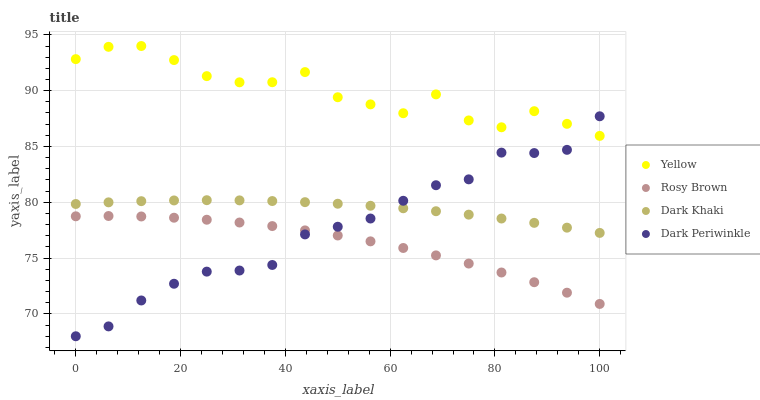Does Rosy Brown have the minimum area under the curve?
Answer yes or no. Yes. Does Yellow have the maximum area under the curve?
Answer yes or no. Yes. Does Dark Periwinkle have the minimum area under the curve?
Answer yes or no. No. Does Dark Periwinkle have the maximum area under the curve?
Answer yes or no. No. Is Dark Khaki the smoothest?
Answer yes or no. Yes. Is Yellow the roughest?
Answer yes or no. Yes. Is Rosy Brown the smoothest?
Answer yes or no. No. Is Rosy Brown the roughest?
Answer yes or no. No. Does Dark Periwinkle have the lowest value?
Answer yes or no. Yes. Does Rosy Brown have the lowest value?
Answer yes or no. No. Does Yellow have the highest value?
Answer yes or no. Yes. Does Dark Periwinkle have the highest value?
Answer yes or no. No. Is Rosy Brown less than Yellow?
Answer yes or no. Yes. Is Dark Khaki greater than Rosy Brown?
Answer yes or no. Yes. Does Rosy Brown intersect Dark Periwinkle?
Answer yes or no. Yes. Is Rosy Brown less than Dark Periwinkle?
Answer yes or no. No. Is Rosy Brown greater than Dark Periwinkle?
Answer yes or no. No. Does Rosy Brown intersect Yellow?
Answer yes or no. No. 